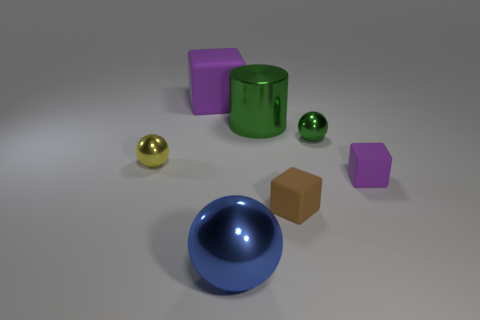Are there any patterns or consistencies among the objects here? Yes, there are certain consistencies present. Color is a theme since there are duplicates of purple cubes and both green items share the same hue. In terms of shape, there are two spheres and two cubes. These could indicate a pattern to showcase variety in both shape and color. 